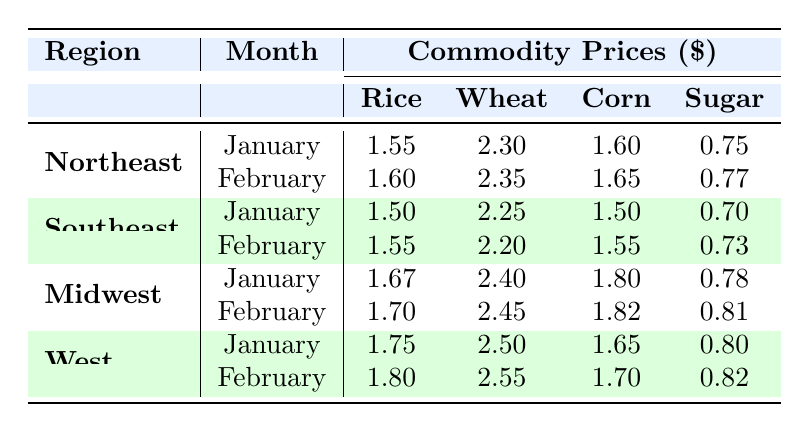What is the price of rice in the Midwest in February? The table lists the rice price for the Midwest region in February as 1.70.
Answer: 1.70 Which region had the highest sugar price in January? By looking at the sugar prices for each region in January: Northeast (0.75), Southeast (0.70), Midwest (0.78), and West (0.80), the West has the highest price of 0.80.
Answer: West What is the average wheat price in the Southeast region across January and February? The wheat prices in the Southeast for January and February are 2.25 and 2.20, respectively. Their sum is 2.25 + 2.20 = 4.45. The average is 4.45 / 2 = 2.225.
Answer: 2.225 Did the price of corn in the Northeast increase from January to February? The corn price in Northeast is 1.60 in January and increases to 1.65 in February; therefore, the price did increase.
Answer: Yes What is the difference in rice prices between the Northeast and Midwest regions in January? The rice price in the Northeast in January is 1.55, and in the Midwest it is 1.67. The difference is 1.67 - 1.55 = 0.12.
Answer: 0.12 Which commodity had a price increase in the Midwest from January to February? Analyzing the prices in the Midwest: Rice increased from 1.67 to 1.70, Wheat from 2.40 to 2.45, Corn from 1.80 to 1.82, and Sugar from 0.78 to 0.81. All commodities experienced an increase.
Answer: All commodities What was the lowest wheat price recorded in February among all regions? In February, the wheat prices are: Northeast (2.35), Southeast (2.20), Midwest (2.45), and West (2.55). The lowest price recorded is in the Southeast at 2.20.
Answer: 2.20 Did the sugar price stay the same in the Southeast from January to February? The sugar price in Southeast is listed as 0.70 in January and decreases to 0.73 in February; hence, it did not stay the same.
Answer: No How much did corn prices increase in the West from January to February? The corn price in the West for January is 1.65, and it increases to 1.70 in February. The increase is calculated as 1.70 - 1.65 = 0.05.
Answer: 0.05 